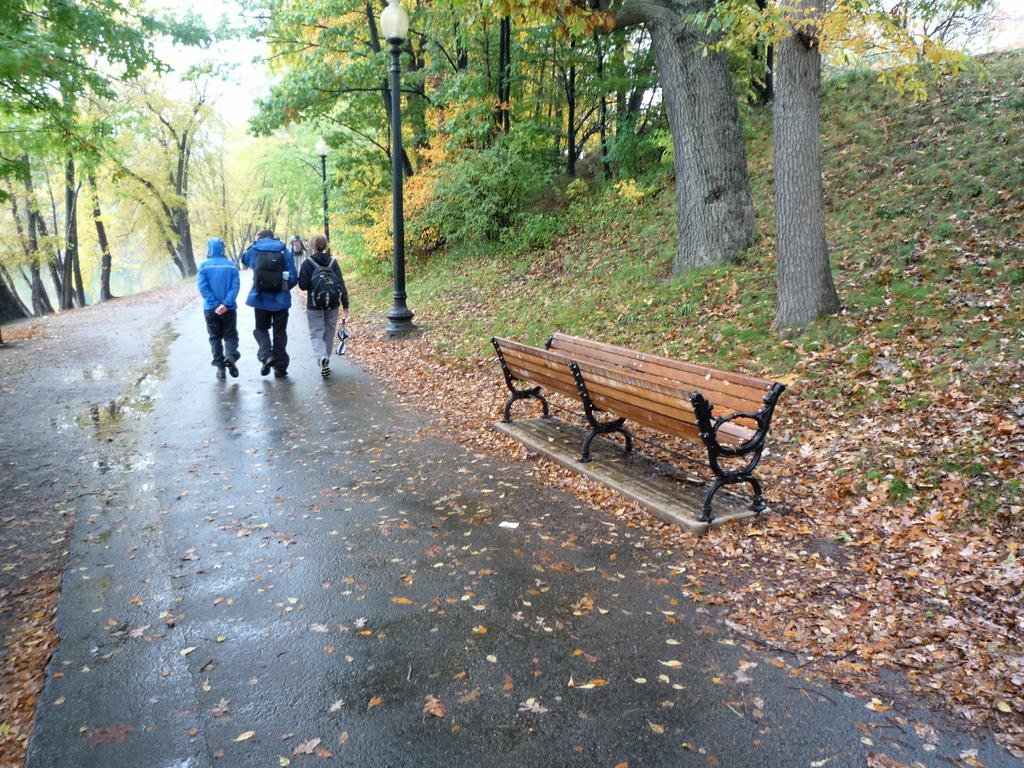What are the people in the image doing? There are three people walking on the road in the image. What type of object can be seen for sitting in the image? There is a bench in the image. What vertical object is present in the image? There is a pole in the image. What type of vegetation is visible in the image? There are trees in the image. What type of sponge can be seen playing the drum in the image? There is no sponge or drum present in the image. 